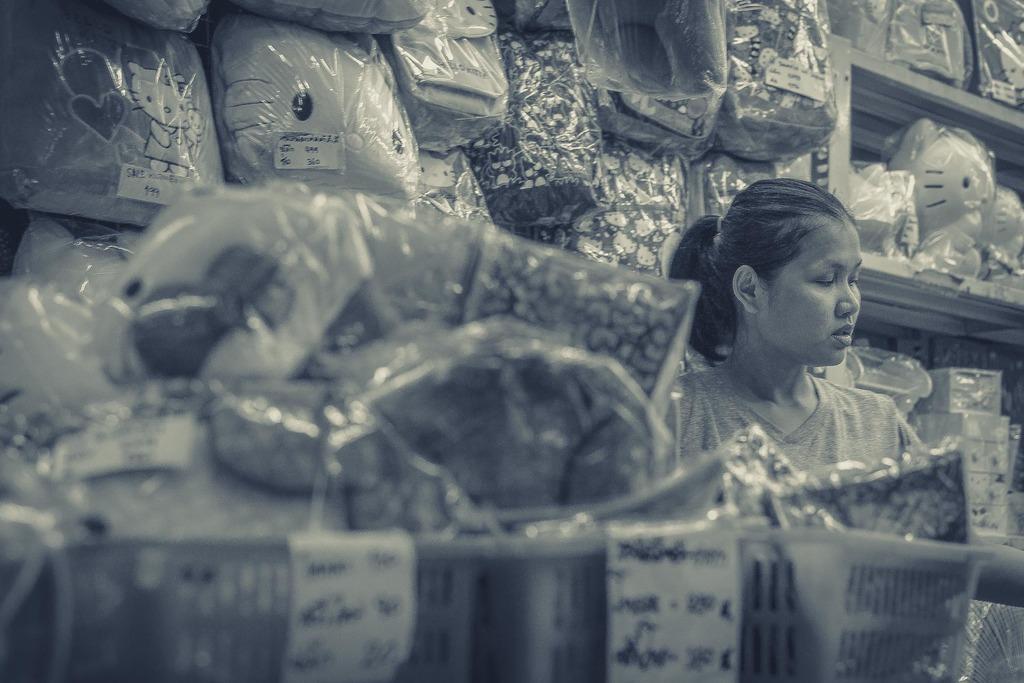Describe this image in one or two sentences. In this image there is a woman, around the women there are a few objects placed on the shelves. 